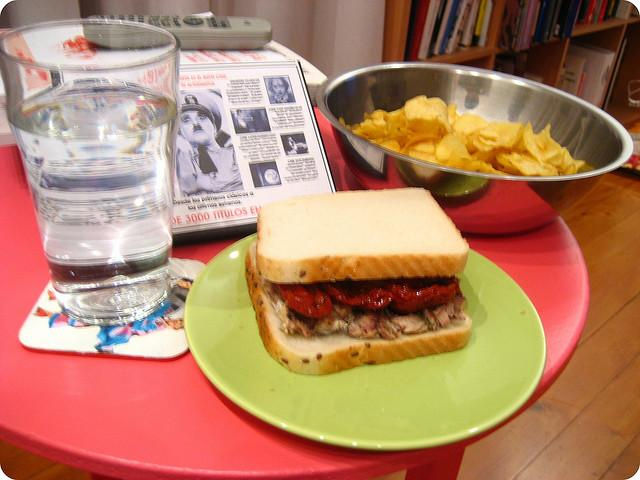What side dish is to be enjoyed with this sandwich?

Choices:
A) pears
B) potato chips
C) bacon
D) apples potato chips 